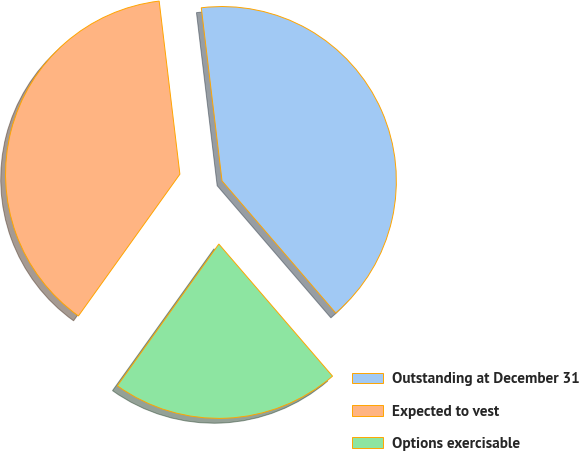Convert chart. <chart><loc_0><loc_0><loc_500><loc_500><pie_chart><fcel>Outstanding at December 31<fcel>Expected to vest<fcel>Options exercisable<nl><fcel>40.59%<fcel>38.22%<fcel>21.2%<nl></chart> 